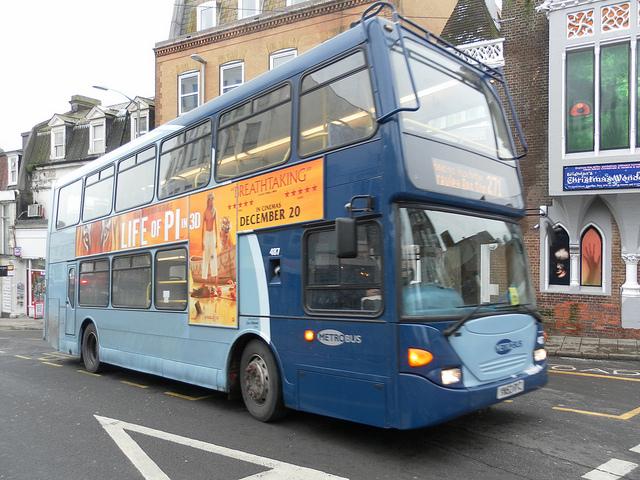What color is the bus?
Keep it brief. Blue. The sign says Life of what?
Short answer required. Pi. What does the blue square symbol on the front of the bus mean?
Be succinct. Nothing. What does this bus run on?
Give a very brief answer. Gas. What date appears for the movie?
Short answer required. December 20. 